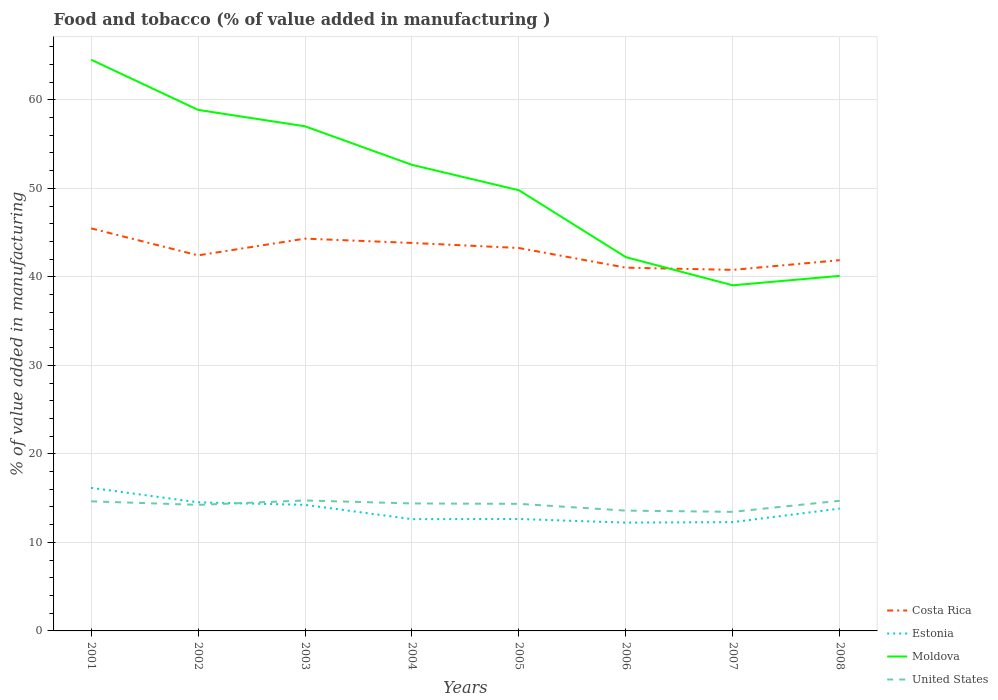Across all years, what is the maximum value added in manufacturing food and tobacco in Estonia?
Give a very brief answer. 12.23. What is the total value added in manufacturing food and tobacco in Costa Rica in the graph?
Offer a very short reply. 4.44. What is the difference between the highest and the second highest value added in manufacturing food and tobacco in Costa Rica?
Offer a very short reply. 4.69. How many lines are there?
Offer a very short reply. 4. What is the difference between two consecutive major ticks on the Y-axis?
Make the answer very short. 10. Are the values on the major ticks of Y-axis written in scientific E-notation?
Your answer should be compact. No. Does the graph contain grids?
Provide a succinct answer. Yes. Where does the legend appear in the graph?
Provide a short and direct response. Bottom right. What is the title of the graph?
Your answer should be compact. Food and tobacco (% of value added in manufacturing ). What is the label or title of the X-axis?
Your answer should be very brief. Years. What is the label or title of the Y-axis?
Make the answer very short. % of value added in manufacturing. What is the % of value added in manufacturing in Costa Rica in 2001?
Offer a terse response. 45.47. What is the % of value added in manufacturing in Estonia in 2001?
Your response must be concise. 16.16. What is the % of value added in manufacturing of Moldova in 2001?
Offer a terse response. 64.52. What is the % of value added in manufacturing in United States in 2001?
Your answer should be compact. 14.64. What is the % of value added in manufacturing in Costa Rica in 2002?
Give a very brief answer. 42.42. What is the % of value added in manufacturing in Estonia in 2002?
Offer a terse response. 14.53. What is the % of value added in manufacturing of Moldova in 2002?
Give a very brief answer. 58.86. What is the % of value added in manufacturing in United States in 2002?
Make the answer very short. 14.24. What is the % of value added in manufacturing in Costa Rica in 2003?
Your response must be concise. 44.31. What is the % of value added in manufacturing in Estonia in 2003?
Your response must be concise. 14.24. What is the % of value added in manufacturing of Moldova in 2003?
Offer a very short reply. 57. What is the % of value added in manufacturing of United States in 2003?
Offer a terse response. 14.74. What is the % of value added in manufacturing in Costa Rica in 2004?
Make the answer very short. 43.83. What is the % of value added in manufacturing of Estonia in 2004?
Provide a succinct answer. 12.63. What is the % of value added in manufacturing in Moldova in 2004?
Make the answer very short. 52.65. What is the % of value added in manufacturing of United States in 2004?
Ensure brevity in your answer.  14.4. What is the % of value added in manufacturing in Costa Rica in 2005?
Provide a short and direct response. 43.26. What is the % of value added in manufacturing of Estonia in 2005?
Provide a succinct answer. 12.64. What is the % of value added in manufacturing in Moldova in 2005?
Keep it short and to the point. 49.78. What is the % of value added in manufacturing of United States in 2005?
Provide a short and direct response. 14.35. What is the % of value added in manufacturing of Costa Rica in 2006?
Provide a short and direct response. 41.04. What is the % of value added in manufacturing in Estonia in 2006?
Provide a succinct answer. 12.23. What is the % of value added in manufacturing in Moldova in 2006?
Ensure brevity in your answer.  42.22. What is the % of value added in manufacturing of United States in 2006?
Provide a succinct answer. 13.59. What is the % of value added in manufacturing in Costa Rica in 2007?
Provide a succinct answer. 40.78. What is the % of value added in manufacturing in Estonia in 2007?
Your answer should be compact. 12.29. What is the % of value added in manufacturing in Moldova in 2007?
Your answer should be very brief. 39.04. What is the % of value added in manufacturing of United States in 2007?
Provide a succinct answer. 13.45. What is the % of value added in manufacturing of Costa Rica in 2008?
Your answer should be very brief. 41.88. What is the % of value added in manufacturing in Estonia in 2008?
Your response must be concise. 13.82. What is the % of value added in manufacturing in Moldova in 2008?
Keep it short and to the point. 40.11. What is the % of value added in manufacturing of United States in 2008?
Offer a terse response. 14.71. Across all years, what is the maximum % of value added in manufacturing of Costa Rica?
Offer a very short reply. 45.47. Across all years, what is the maximum % of value added in manufacturing in Estonia?
Keep it short and to the point. 16.16. Across all years, what is the maximum % of value added in manufacturing of Moldova?
Provide a succinct answer. 64.52. Across all years, what is the maximum % of value added in manufacturing of United States?
Ensure brevity in your answer.  14.74. Across all years, what is the minimum % of value added in manufacturing in Costa Rica?
Offer a terse response. 40.78. Across all years, what is the minimum % of value added in manufacturing of Estonia?
Give a very brief answer. 12.23. Across all years, what is the minimum % of value added in manufacturing of Moldova?
Make the answer very short. 39.04. Across all years, what is the minimum % of value added in manufacturing of United States?
Ensure brevity in your answer.  13.45. What is the total % of value added in manufacturing of Costa Rica in the graph?
Offer a terse response. 342.99. What is the total % of value added in manufacturing of Estonia in the graph?
Your response must be concise. 108.54. What is the total % of value added in manufacturing in Moldova in the graph?
Your response must be concise. 404.19. What is the total % of value added in manufacturing in United States in the graph?
Ensure brevity in your answer.  114.12. What is the difference between the % of value added in manufacturing in Costa Rica in 2001 and that in 2002?
Provide a succinct answer. 3.05. What is the difference between the % of value added in manufacturing of Estonia in 2001 and that in 2002?
Ensure brevity in your answer.  1.63. What is the difference between the % of value added in manufacturing of Moldova in 2001 and that in 2002?
Ensure brevity in your answer.  5.67. What is the difference between the % of value added in manufacturing of United States in 2001 and that in 2002?
Your answer should be compact. 0.4. What is the difference between the % of value added in manufacturing of Costa Rica in 2001 and that in 2003?
Offer a very short reply. 1.16. What is the difference between the % of value added in manufacturing of Estonia in 2001 and that in 2003?
Provide a short and direct response. 1.92. What is the difference between the % of value added in manufacturing of Moldova in 2001 and that in 2003?
Your answer should be very brief. 7.52. What is the difference between the % of value added in manufacturing of United States in 2001 and that in 2003?
Your answer should be compact. -0.1. What is the difference between the % of value added in manufacturing of Costa Rica in 2001 and that in 2004?
Give a very brief answer. 1.65. What is the difference between the % of value added in manufacturing in Estonia in 2001 and that in 2004?
Your answer should be very brief. 3.53. What is the difference between the % of value added in manufacturing in Moldova in 2001 and that in 2004?
Provide a succinct answer. 11.87. What is the difference between the % of value added in manufacturing of United States in 2001 and that in 2004?
Keep it short and to the point. 0.24. What is the difference between the % of value added in manufacturing of Costa Rica in 2001 and that in 2005?
Provide a succinct answer. 2.22. What is the difference between the % of value added in manufacturing of Estonia in 2001 and that in 2005?
Offer a very short reply. 3.52. What is the difference between the % of value added in manufacturing of Moldova in 2001 and that in 2005?
Your answer should be very brief. 14.75. What is the difference between the % of value added in manufacturing in United States in 2001 and that in 2005?
Give a very brief answer. 0.29. What is the difference between the % of value added in manufacturing of Costa Rica in 2001 and that in 2006?
Provide a succinct answer. 4.44. What is the difference between the % of value added in manufacturing in Estonia in 2001 and that in 2006?
Make the answer very short. 3.92. What is the difference between the % of value added in manufacturing in Moldova in 2001 and that in 2006?
Provide a succinct answer. 22.3. What is the difference between the % of value added in manufacturing in United States in 2001 and that in 2006?
Give a very brief answer. 1.05. What is the difference between the % of value added in manufacturing in Costa Rica in 2001 and that in 2007?
Give a very brief answer. 4.69. What is the difference between the % of value added in manufacturing in Estonia in 2001 and that in 2007?
Your response must be concise. 3.87. What is the difference between the % of value added in manufacturing in Moldova in 2001 and that in 2007?
Give a very brief answer. 25.48. What is the difference between the % of value added in manufacturing in United States in 2001 and that in 2007?
Provide a short and direct response. 1.19. What is the difference between the % of value added in manufacturing of Costa Rica in 2001 and that in 2008?
Your response must be concise. 3.59. What is the difference between the % of value added in manufacturing in Estonia in 2001 and that in 2008?
Ensure brevity in your answer.  2.34. What is the difference between the % of value added in manufacturing in Moldova in 2001 and that in 2008?
Your response must be concise. 24.42. What is the difference between the % of value added in manufacturing in United States in 2001 and that in 2008?
Provide a succinct answer. -0.06. What is the difference between the % of value added in manufacturing in Costa Rica in 2002 and that in 2003?
Offer a terse response. -1.89. What is the difference between the % of value added in manufacturing of Estonia in 2002 and that in 2003?
Give a very brief answer. 0.29. What is the difference between the % of value added in manufacturing in Moldova in 2002 and that in 2003?
Offer a very short reply. 1.86. What is the difference between the % of value added in manufacturing in United States in 2002 and that in 2003?
Your response must be concise. -0.5. What is the difference between the % of value added in manufacturing in Costa Rica in 2002 and that in 2004?
Provide a succinct answer. -1.4. What is the difference between the % of value added in manufacturing of Estonia in 2002 and that in 2004?
Provide a short and direct response. 1.9. What is the difference between the % of value added in manufacturing of Moldova in 2002 and that in 2004?
Offer a very short reply. 6.21. What is the difference between the % of value added in manufacturing of United States in 2002 and that in 2004?
Give a very brief answer. -0.16. What is the difference between the % of value added in manufacturing in Costa Rica in 2002 and that in 2005?
Keep it short and to the point. -0.83. What is the difference between the % of value added in manufacturing of Estonia in 2002 and that in 2005?
Keep it short and to the point. 1.88. What is the difference between the % of value added in manufacturing in Moldova in 2002 and that in 2005?
Give a very brief answer. 9.08. What is the difference between the % of value added in manufacturing in United States in 2002 and that in 2005?
Provide a short and direct response. -0.12. What is the difference between the % of value added in manufacturing of Costa Rica in 2002 and that in 2006?
Offer a very short reply. 1.39. What is the difference between the % of value added in manufacturing of Estonia in 2002 and that in 2006?
Give a very brief answer. 2.29. What is the difference between the % of value added in manufacturing of Moldova in 2002 and that in 2006?
Your response must be concise. 16.64. What is the difference between the % of value added in manufacturing in United States in 2002 and that in 2006?
Provide a short and direct response. 0.65. What is the difference between the % of value added in manufacturing of Costa Rica in 2002 and that in 2007?
Offer a terse response. 1.64. What is the difference between the % of value added in manufacturing of Estonia in 2002 and that in 2007?
Keep it short and to the point. 2.24. What is the difference between the % of value added in manufacturing in Moldova in 2002 and that in 2007?
Provide a succinct answer. 19.82. What is the difference between the % of value added in manufacturing of United States in 2002 and that in 2007?
Provide a short and direct response. 0.79. What is the difference between the % of value added in manufacturing in Costa Rica in 2002 and that in 2008?
Make the answer very short. 0.54. What is the difference between the % of value added in manufacturing in Estonia in 2002 and that in 2008?
Your answer should be very brief. 0.71. What is the difference between the % of value added in manufacturing of Moldova in 2002 and that in 2008?
Your answer should be compact. 18.75. What is the difference between the % of value added in manufacturing of United States in 2002 and that in 2008?
Your answer should be very brief. -0.47. What is the difference between the % of value added in manufacturing of Costa Rica in 2003 and that in 2004?
Provide a succinct answer. 0.49. What is the difference between the % of value added in manufacturing in Estonia in 2003 and that in 2004?
Offer a very short reply. 1.62. What is the difference between the % of value added in manufacturing in Moldova in 2003 and that in 2004?
Ensure brevity in your answer.  4.35. What is the difference between the % of value added in manufacturing of United States in 2003 and that in 2004?
Offer a very short reply. 0.34. What is the difference between the % of value added in manufacturing of Costa Rica in 2003 and that in 2005?
Offer a terse response. 1.06. What is the difference between the % of value added in manufacturing of Estonia in 2003 and that in 2005?
Provide a succinct answer. 1.6. What is the difference between the % of value added in manufacturing in Moldova in 2003 and that in 2005?
Provide a short and direct response. 7.22. What is the difference between the % of value added in manufacturing in United States in 2003 and that in 2005?
Your answer should be very brief. 0.38. What is the difference between the % of value added in manufacturing of Costa Rica in 2003 and that in 2006?
Your response must be concise. 3.28. What is the difference between the % of value added in manufacturing in Estonia in 2003 and that in 2006?
Your answer should be compact. 2.01. What is the difference between the % of value added in manufacturing in Moldova in 2003 and that in 2006?
Offer a terse response. 14.78. What is the difference between the % of value added in manufacturing of United States in 2003 and that in 2006?
Give a very brief answer. 1.15. What is the difference between the % of value added in manufacturing of Costa Rica in 2003 and that in 2007?
Your answer should be compact. 3.53. What is the difference between the % of value added in manufacturing of Estonia in 2003 and that in 2007?
Provide a short and direct response. 1.95. What is the difference between the % of value added in manufacturing of Moldova in 2003 and that in 2007?
Offer a very short reply. 17.96. What is the difference between the % of value added in manufacturing of United States in 2003 and that in 2007?
Your answer should be very brief. 1.29. What is the difference between the % of value added in manufacturing of Costa Rica in 2003 and that in 2008?
Provide a succinct answer. 2.43. What is the difference between the % of value added in manufacturing of Estonia in 2003 and that in 2008?
Give a very brief answer. 0.42. What is the difference between the % of value added in manufacturing of Moldova in 2003 and that in 2008?
Ensure brevity in your answer.  16.9. What is the difference between the % of value added in manufacturing of United States in 2003 and that in 2008?
Provide a succinct answer. 0.03. What is the difference between the % of value added in manufacturing in Costa Rica in 2004 and that in 2005?
Provide a short and direct response. 0.57. What is the difference between the % of value added in manufacturing of Estonia in 2004 and that in 2005?
Your answer should be compact. -0.02. What is the difference between the % of value added in manufacturing of Moldova in 2004 and that in 2005?
Offer a terse response. 2.87. What is the difference between the % of value added in manufacturing in United States in 2004 and that in 2005?
Provide a short and direct response. 0.04. What is the difference between the % of value added in manufacturing of Costa Rica in 2004 and that in 2006?
Your answer should be compact. 2.79. What is the difference between the % of value added in manufacturing in Estonia in 2004 and that in 2006?
Keep it short and to the point. 0.39. What is the difference between the % of value added in manufacturing of Moldova in 2004 and that in 2006?
Your answer should be compact. 10.43. What is the difference between the % of value added in manufacturing in United States in 2004 and that in 2006?
Make the answer very short. 0.81. What is the difference between the % of value added in manufacturing of Costa Rica in 2004 and that in 2007?
Provide a succinct answer. 3.04. What is the difference between the % of value added in manufacturing in Estonia in 2004 and that in 2007?
Ensure brevity in your answer.  0.33. What is the difference between the % of value added in manufacturing of Moldova in 2004 and that in 2007?
Make the answer very short. 13.61. What is the difference between the % of value added in manufacturing of United States in 2004 and that in 2007?
Offer a terse response. 0.95. What is the difference between the % of value added in manufacturing in Costa Rica in 2004 and that in 2008?
Make the answer very short. 1.95. What is the difference between the % of value added in manufacturing of Estonia in 2004 and that in 2008?
Make the answer very short. -1.19. What is the difference between the % of value added in manufacturing of Moldova in 2004 and that in 2008?
Ensure brevity in your answer.  12.54. What is the difference between the % of value added in manufacturing in United States in 2004 and that in 2008?
Make the answer very short. -0.31. What is the difference between the % of value added in manufacturing of Costa Rica in 2005 and that in 2006?
Keep it short and to the point. 2.22. What is the difference between the % of value added in manufacturing in Estonia in 2005 and that in 2006?
Your response must be concise. 0.41. What is the difference between the % of value added in manufacturing of Moldova in 2005 and that in 2006?
Provide a succinct answer. 7.56. What is the difference between the % of value added in manufacturing in United States in 2005 and that in 2006?
Offer a very short reply. 0.76. What is the difference between the % of value added in manufacturing in Costa Rica in 2005 and that in 2007?
Offer a very short reply. 2.47. What is the difference between the % of value added in manufacturing in Estonia in 2005 and that in 2007?
Give a very brief answer. 0.35. What is the difference between the % of value added in manufacturing of Moldova in 2005 and that in 2007?
Make the answer very short. 10.74. What is the difference between the % of value added in manufacturing of United States in 2005 and that in 2007?
Offer a very short reply. 0.9. What is the difference between the % of value added in manufacturing in Costa Rica in 2005 and that in 2008?
Offer a very short reply. 1.38. What is the difference between the % of value added in manufacturing in Estonia in 2005 and that in 2008?
Keep it short and to the point. -1.18. What is the difference between the % of value added in manufacturing in Moldova in 2005 and that in 2008?
Provide a short and direct response. 9.67. What is the difference between the % of value added in manufacturing of United States in 2005 and that in 2008?
Ensure brevity in your answer.  -0.35. What is the difference between the % of value added in manufacturing of Costa Rica in 2006 and that in 2007?
Your response must be concise. 0.25. What is the difference between the % of value added in manufacturing of Estonia in 2006 and that in 2007?
Your answer should be very brief. -0.06. What is the difference between the % of value added in manufacturing of Moldova in 2006 and that in 2007?
Offer a very short reply. 3.18. What is the difference between the % of value added in manufacturing in United States in 2006 and that in 2007?
Give a very brief answer. 0.14. What is the difference between the % of value added in manufacturing in Costa Rica in 2006 and that in 2008?
Ensure brevity in your answer.  -0.84. What is the difference between the % of value added in manufacturing in Estonia in 2006 and that in 2008?
Offer a terse response. -1.58. What is the difference between the % of value added in manufacturing in Moldova in 2006 and that in 2008?
Offer a very short reply. 2.11. What is the difference between the % of value added in manufacturing in United States in 2006 and that in 2008?
Your response must be concise. -1.11. What is the difference between the % of value added in manufacturing of Costa Rica in 2007 and that in 2008?
Keep it short and to the point. -1.1. What is the difference between the % of value added in manufacturing in Estonia in 2007 and that in 2008?
Ensure brevity in your answer.  -1.53. What is the difference between the % of value added in manufacturing in Moldova in 2007 and that in 2008?
Your answer should be very brief. -1.06. What is the difference between the % of value added in manufacturing in United States in 2007 and that in 2008?
Offer a terse response. -1.25. What is the difference between the % of value added in manufacturing in Costa Rica in 2001 and the % of value added in manufacturing in Estonia in 2002?
Make the answer very short. 30.95. What is the difference between the % of value added in manufacturing in Costa Rica in 2001 and the % of value added in manufacturing in Moldova in 2002?
Make the answer very short. -13.39. What is the difference between the % of value added in manufacturing of Costa Rica in 2001 and the % of value added in manufacturing of United States in 2002?
Keep it short and to the point. 31.23. What is the difference between the % of value added in manufacturing in Estonia in 2001 and the % of value added in manufacturing in Moldova in 2002?
Provide a short and direct response. -42.7. What is the difference between the % of value added in manufacturing in Estonia in 2001 and the % of value added in manufacturing in United States in 2002?
Provide a short and direct response. 1.92. What is the difference between the % of value added in manufacturing of Moldova in 2001 and the % of value added in manufacturing of United States in 2002?
Keep it short and to the point. 50.29. What is the difference between the % of value added in manufacturing of Costa Rica in 2001 and the % of value added in manufacturing of Estonia in 2003?
Give a very brief answer. 31.23. What is the difference between the % of value added in manufacturing in Costa Rica in 2001 and the % of value added in manufacturing in Moldova in 2003?
Provide a succinct answer. -11.53. What is the difference between the % of value added in manufacturing of Costa Rica in 2001 and the % of value added in manufacturing of United States in 2003?
Your answer should be compact. 30.73. What is the difference between the % of value added in manufacturing of Estonia in 2001 and the % of value added in manufacturing of Moldova in 2003?
Offer a very short reply. -40.84. What is the difference between the % of value added in manufacturing of Estonia in 2001 and the % of value added in manufacturing of United States in 2003?
Your response must be concise. 1.42. What is the difference between the % of value added in manufacturing in Moldova in 2001 and the % of value added in manufacturing in United States in 2003?
Give a very brief answer. 49.79. What is the difference between the % of value added in manufacturing of Costa Rica in 2001 and the % of value added in manufacturing of Estonia in 2004?
Your answer should be compact. 32.85. What is the difference between the % of value added in manufacturing of Costa Rica in 2001 and the % of value added in manufacturing of Moldova in 2004?
Keep it short and to the point. -7.18. What is the difference between the % of value added in manufacturing of Costa Rica in 2001 and the % of value added in manufacturing of United States in 2004?
Provide a succinct answer. 31.07. What is the difference between the % of value added in manufacturing of Estonia in 2001 and the % of value added in manufacturing of Moldova in 2004?
Give a very brief answer. -36.49. What is the difference between the % of value added in manufacturing in Estonia in 2001 and the % of value added in manufacturing in United States in 2004?
Offer a terse response. 1.76. What is the difference between the % of value added in manufacturing of Moldova in 2001 and the % of value added in manufacturing of United States in 2004?
Keep it short and to the point. 50.12. What is the difference between the % of value added in manufacturing of Costa Rica in 2001 and the % of value added in manufacturing of Estonia in 2005?
Keep it short and to the point. 32.83. What is the difference between the % of value added in manufacturing of Costa Rica in 2001 and the % of value added in manufacturing of Moldova in 2005?
Give a very brief answer. -4.31. What is the difference between the % of value added in manufacturing in Costa Rica in 2001 and the % of value added in manufacturing in United States in 2005?
Provide a succinct answer. 31.12. What is the difference between the % of value added in manufacturing in Estonia in 2001 and the % of value added in manufacturing in Moldova in 2005?
Provide a succinct answer. -33.62. What is the difference between the % of value added in manufacturing of Estonia in 2001 and the % of value added in manufacturing of United States in 2005?
Provide a short and direct response. 1.8. What is the difference between the % of value added in manufacturing in Moldova in 2001 and the % of value added in manufacturing in United States in 2005?
Ensure brevity in your answer.  50.17. What is the difference between the % of value added in manufacturing in Costa Rica in 2001 and the % of value added in manufacturing in Estonia in 2006?
Offer a terse response. 33.24. What is the difference between the % of value added in manufacturing in Costa Rica in 2001 and the % of value added in manufacturing in Moldova in 2006?
Make the answer very short. 3.25. What is the difference between the % of value added in manufacturing of Costa Rica in 2001 and the % of value added in manufacturing of United States in 2006?
Ensure brevity in your answer.  31.88. What is the difference between the % of value added in manufacturing of Estonia in 2001 and the % of value added in manufacturing of Moldova in 2006?
Keep it short and to the point. -26.06. What is the difference between the % of value added in manufacturing in Estonia in 2001 and the % of value added in manufacturing in United States in 2006?
Ensure brevity in your answer.  2.57. What is the difference between the % of value added in manufacturing of Moldova in 2001 and the % of value added in manufacturing of United States in 2006?
Provide a succinct answer. 50.93. What is the difference between the % of value added in manufacturing in Costa Rica in 2001 and the % of value added in manufacturing in Estonia in 2007?
Provide a succinct answer. 33.18. What is the difference between the % of value added in manufacturing of Costa Rica in 2001 and the % of value added in manufacturing of Moldova in 2007?
Provide a succinct answer. 6.43. What is the difference between the % of value added in manufacturing in Costa Rica in 2001 and the % of value added in manufacturing in United States in 2007?
Give a very brief answer. 32.02. What is the difference between the % of value added in manufacturing of Estonia in 2001 and the % of value added in manufacturing of Moldova in 2007?
Give a very brief answer. -22.88. What is the difference between the % of value added in manufacturing of Estonia in 2001 and the % of value added in manufacturing of United States in 2007?
Ensure brevity in your answer.  2.71. What is the difference between the % of value added in manufacturing of Moldova in 2001 and the % of value added in manufacturing of United States in 2007?
Your response must be concise. 51.07. What is the difference between the % of value added in manufacturing in Costa Rica in 2001 and the % of value added in manufacturing in Estonia in 2008?
Your answer should be compact. 31.65. What is the difference between the % of value added in manufacturing of Costa Rica in 2001 and the % of value added in manufacturing of Moldova in 2008?
Your response must be concise. 5.37. What is the difference between the % of value added in manufacturing of Costa Rica in 2001 and the % of value added in manufacturing of United States in 2008?
Offer a very short reply. 30.77. What is the difference between the % of value added in manufacturing of Estonia in 2001 and the % of value added in manufacturing of Moldova in 2008?
Ensure brevity in your answer.  -23.95. What is the difference between the % of value added in manufacturing in Estonia in 2001 and the % of value added in manufacturing in United States in 2008?
Give a very brief answer. 1.45. What is the difference between the % of value added in manufacturing of Moldova in 2001 and the % of value added in manufacturing of United States in 2008?
Ensure brevity in your answer.  49.82. What is the difference between the % of value added in manufacturing in Costa Rica in 2002 and the % of value added in manufacturing in Estonia in 2003?
Your response must be concise. 28.18. What is the difference between the % of value added in manufacturing in Costa Rica in 2002 and the % of value added in manufacturing in Moldova in 2003?
Your response must be concise. -14.58. What is the difference between the % of value added in manufacturing of Costa Rica in 2002 and the % of value added in manufacturing of United States in 2003?
Keep it short and to the point. 27.69. What is the difference between the % of value added in manufacturing of Estonia in 2002 and the % of value added in manufacturing of Moldova in 2003?
Offer a very short reply. -42.48. What is the difference between the % of value added in manufacturing in Estonia in 2002 and the % of value added in manufacturing in United States in 2003?
Ensure brevity in your answer.  -0.21. What is the difference between the % of value added in manufacturing in Moldova in 2002 and the % of value added in manufacturing in United States in 2003?
Keep it short and to the point. 44.12. What is the difference between the % of value added in manufacturing of Costa Rica in 2002 and the % of value added in manufacturing of Estonia in 2004?
Provide a succinct answer. 29.8. What is the difference between the % of value added in manufacturing of Costa Rica in 2002 and the % of value added in manufacturing of Moldova in 2004?
Offer a terse response. -10.22. What is the difference between the % of value added in manufacturing of Costa Rica in 2002 and the % of value added in manufacturing of United States in 2004?
Make the answer very short. 28.03. What is the difference between the % of value added in manufacturing in Estonia in 2002 and the % of value added in manufacturing in Moldova in 2004?
Make the answer very short. -38.12. What is the difference between the % of value added in manufacturing in Estonia in 2002 and the % of value added in manufacturing in United States in 2004?
Make the answer very short. 0.13. What is the difference between the % of value added in manufacturing of Moldova in 2002 and the % of value added in manufacturing of United States in 2004?
Offer a very short reply. 44.46. What is the difference between the % of value added in manufacturing of Costa Rica in 2002 and the % of value added in manufacturing of Estonia in 2005?
Provide a short and direct response. 29.78. What is the difference between the % of value added in manufacturing of Costa Rica in 2002 and the % of value added in manufacturing of Moldova in 2005?
Make the answer very short. -7.35. What is the difference between the % of value added in manufacturing in Costa Rica in 2002 and the % of value added in manufacturing in United States in 2005?
Give a very brief answer. 28.07. What is the difference between the % of value added in manufacturing in Estonia in 2002 and the % of value added in manufacturing in Moldova in 2005?
Give a very brief answer. -35.25. What is the difference between the % of value added in manufacturing of Estonia in 2002 and the % of value added in manufacturing of United States in 2005?
Offer a very short reply. 0.17. What is the difference between the % of value added in manufacturing of Moldova in 2002 and the % of value added in manufacturing of United States in 2005?
Make the answer very short. 44.5. What is the difference between the % of value added in manufacturing of Costa Rica in 2002 and the % of value added in manufacturing of Estonia in 2006?
Your answer should be very brief. 30.19. What is the difference between the % of value added in manufacturing in Costa Rica in 2002 and the % of value added in manufacturing in Moldova in 2006?
Your response must be concise. 0.2. What is the difference between the % of value added in manufacturing of Costa Rica in 2002 and the % of value added in manufacturing of United States in 2006?
Provide a short and direct response. 28.83. What is the difference between the % of value added in manufacturing of Estonia in 2002 and the % of value added in manufacturing of Moldova in 2006?
Provide a short and direct response. -27.7. What is the difference between the % of value added in manufacturing in Estonia in 2002 and the % of value added in manufacturing in United States in 2006?
Make the answer very short. 0.94. What is the difference between the % of value added in manufacturing in Moldova in 2002 and the % of value added in manufacturing in United States in 2006?
Offer a very short reply. 45.27. What is the difference between the % of value added in manufacturing in Costa Rica in 2002 and the % of value added in manufacturing in Estonia in 2007?
Provide a succinct answer. 30.13. What is the difference between the % of value added in manufacturing in Costa Rica in 2002 and the % of value added in manufacturing in Moldova in 2007?
Provide a succinct answer. 3.38. What is the difference between the % of value added in manufacturing in Costa Rica in 2002 and the % of value added in manufacturing in United States in 2007?
Provide a succinct answer. 28.97. What is the difference between the % of value added in manufacturing of Estonia in 2002 and the % of value added in manufacturing of Moldova in 2007?
Your answer should be compact. -24.52. What is the difference between the % of value added in manufacturing in Estonia in 2002 and the % of value added in manufacturing in United States in 2007?
Your response must be concise. 1.08. What is the difference between the % of value added in manufacturing of Moldova in 2002 and the % of value added in manufacturing of United States in 2007?
Ensure brevity in your answer.  45.41. What is the difference between the % of value added in manufacturing in Costa Rica in 2002 and the % of value added in manufacturing in Estonia in 2008?
Provide a short and direct response. 28.61. What is the difference between the % of value added in manufacturing of Costa Rica in 2002 and the % of value added in manufacturing of Moldova in 2008?
Your response must be concise. 2.32. What is the difference between the % of value added in manufacturing in Costa Rica in 2002 and the % of value added in manufacturing in United States in 2008?
Ensure brevity in your answer.  27.72. What is the difference between the % of value added in manufacturing of Estonia in 2002 and the % of value added in manufacturing of Moldova in 2008?
Provide a succinct answer. -25.58. What is the difference between the % of value added in manufacturing in Estonia in 2002 and the % of value added in manufacturing in United States in 2008?
Ensure brevity in your answer.  -0.18. What is the difference between the % of value added in manufacturing of Moldova in 2002 and the % of value added in manufacturing of United States in 2008?
Your response must be concise. 44.15. What is the difference between the % of value added in manufacturing in Costa Rica in 2003 and the % of value added in manufacturing in Estonia in 2004?
Ensure brevity in your answer.  31.69. What is the difference between the % of value added in manufacturing of Costa Rica in 2003 and the % of value added in manufacturing of Moldova in 2004?
Provide a short and direct response. -8.34. What is the difference between the % of value added in manufacturing in Costa Rica in 2003 and the % of value added in manufacturing in United States in 2004?
Offer a very short reply. 29.91. What is the difference between the % of value added in manufacturing of Estonia in 2003 and the % of value added in manufacturing of Moldova in 2004?
Your response must be concise. -38.41. What is the difference between the % of value added in manufacturing of Estonia in 2003 and the % of value added in manufacturing of United States in 2004?
Your answer should be very brief. -0.16. What is the difference between the % of value added in manufacturing of Moldova in 2003 and the % of value added in manufacturing of United States in 2004?
Provide a succinct answer. 42.6. What is the difference between the % of value added in manufacturing of Costa Rica in 2003 and the % of value added in manufacturing of Estonia in 2005?
Offer a terse response. 31.67. What is the difference between the % of value added in manufacturing in Costa Rica in 2003 and the % of value added in manufacturing in Moldova in 2005?
Ensure brevity in your answer.  -5.47. What is the difference between the % of value added in manufacturing in Costa Rica in 2003 and the % of value added in manufacturing in United States in 2005?
Keep it short and to the point. 29.96. What is the difference between the % of value added in manufacturing in Estonia in 2003 and the % of value added in manufacturing in Moldova in 2005?
Ensure brevity in your answer.  -35.54. What is the difference between the % of value added in manufacturing in Estonia in 2003 and the % of value added in manufacturing in United States in 2005?
Ensure brevity in your answer.  -0.11. What is the difference between the % of value added in manufacturing of Moldova in 2003 and the % of value added in manufacturing of United States in 2005?
Your response must be concise. 42.65. What is the difference between the % of value added in manufacturing in Costa Rica in 2003 and the % of value added in manufacturing in Estonia in 2006?
Provide a short and direct response. 32.08. What is the difference between the % of value added in manufacturing in Costa Rica in 2003 and the % of value added in manufacturing in Moldova in 2006?
Offer a terse response. 2.09. What is the difference between the % of value added in manufacturing in Costa Rica in 2003 and the % of value added in manufacturing in United States in 2006?
Offer a very short reply. 30.72. What is the difference between the % of value added in manufacturing of Estonia in 2003 and the % of value added in manufacturing of Moldova in 2006?
Your answer should be compact. -27.98. What is the difference between the % of value added in manufacturing in Estonia in 2003 and the % of value added in manufacturing in United States in 2006?
Your response must be concise. 0.65. What is the difference between the % of value added in manufacturing in Moldova in 2003 and the % of value added in manufacturing in United States in 2006?
Provide a short and direct response. 43.41. What is the difference between the % of value added in manufacturing of Costa Rica in 2003 and the % of value added in manufacturing of Estonia in 2007?
Offer a terse response. 32.02. What is the difference between the % of value added in manufacturing of Costa Rica in 2003 and the % of value added in manufacturing of Moldova in 2007?
Your response must be concise. 5.27. What is the difference between the % of value added in manufacturing of Costa Rica in 2003 and the % of value added in manufacturing of United States in 2007?
Ensure brevity in your answer.  30.86. What is the difference between the % of value added in manufacturing in Estonia in 2003 and the % of value added in manufacturing in Moldova in 2007?
Your response must be concise. -24.8. What is the difference between the % of value added in manufacturing in Estonia in 2003 and the % of value added in manufacturing in United States in 2007?
Your answer should be compact. 0.79. What is the difference between the % of value added in manufacturing of Moldova in 2003 and the % of value added in manufacturing of United States in 2007?
Your answer should be very brief. 43.55. What is the difference between the % of value added in manufacturing in Costa Rica in 2003 and the % of value added in manufacturing in Estonia in 2008?
Keep it short and to the point. 30.49. What is the difference between the % of value added in manufacturing in Costa Rica in 2003 and the % of value added in manufacturing in Moldova in 2008?
Your answer should be very brief. 4.21. What is the difference between the % of value added in manufacturing in Costa Rica in 2003 and the % of value added in manufacturing in United States in 2008?
Your answer should be very brief. 29.61. What is the difference between the % of value added in manufacturing in Estonia in 2003 and the % of value added in manufacturing in Moldova in 2008?
Provide a short and direct response. -25.87. What is the difference between the % of value added in manufacturing of Estonia in 2003 and the % of value added in manufacturing of United States in 2008?
Keep it short and to the point. -0.46. What is the difference between the % of value added in manufacturing in Moldova in 2003 and the % of value added in manufacturing in United States in 2008?
Give a very brief answer. 42.3. What is the difference between the % of value added in manufacturing in Costa Rica in 2004 and the % of value added in manufacturing in Estonia in 2005?
Keep it short and to the point. 31.18. What is the difference between the % of value added in manufacturing of Costa Rica in 2004 and the % of value added in manufacturing of Moldova in 2005?
Offer a very short reply. -5.95. What is the difference between the % of value added in manufacturing of Costa Rica in 2004 and the % of value added in manufacturing of United States in 2005?
Ensure brevity in your answer.  29.47. What is the difference between the % of value added in manufacturing in Estonia in 2004 and the % of value added in manufacturing in Moldova in 2005?
Make the answer very short. -37.15. What is the difference between the % of value added in manufacturing in Estonia in 2004 and the % of value added in manufacturing in United States in 2005?
Ensure brevity in your answer.  -1.73. What is the difference between the % of value added in manufacturing of Moldova in 2004 and the % of value added in manufacturing of United States in 2005?
Your response must be concise. 38.29. What is the difference between the % of value added in manufacturing of Costa Rica in 2004 and the % of value added in manufacturing of Estonia in 2006?
Offer a very short reply. 31.59. What is the difference between the % of value added in manufacturing of Costa Rica in 2004 and the % of value added in manufacturing of Moldova in 2006?
Give a very brief answer. 1.6. What is the difference between the % of value added in manufacturing of Costa Rica in 2004 and the % of value added in manufacturing of United States in 2006?
Your answer should be compact. 30.24. What is the difference between the % of value added in manufacturing in Estonia in 2004 and the % of value added in manufacturing in Moldova in 2006?
Your response must be concise. -29.6. What is the difference between the % of value added in manufacturing in Estonia in 2004 and the % of value added in manufacturing in United States in 2006?
Make the answer very short. -0.96. What is the difference between the % of value added in manufacturing in Moldova in 2004 and the % of value added in manufacturing in United States in 2006?
Offer a very short reply. 39.06. What is the difference between the % of value added in manufacturing of Costa Rica in 2004 and the % of value added in manufacturing of Estonia in 2007?
Keep it short and to the point. 31.54. What is the difference between the % of value added in manufacturing of Costa Rica in 2004 and the % of value added in manufacturing of Moldova in 2007?
Your answer should be compact. 4.78. What is the difference between the % of value added in manufacturing of Costa Rica in 2004 and the % of value added in manufacturing of United States in 2007?
Give a very brief answer. 30.38. What is the difference between the % of value added in manufacturing of Estonia in 2004 and the % of value added in manufacturing of Moldova in 2007?
Your answer should be very brief. -26.42. What is the difference between the % of value added in manufacturing in Estonia in 2004 and the % of value added in manufacturing in United States in 2007?
Your answer should be very brief. -0.83. What is the difference between the % of value added in manufacturing in Moldova in 2004 and the % of value added in manufacturing in United States in 2007?
Provide a short and direct response. 39.2. What is the difference between the % of value added in manufacturing in Costa Rica in 2004 and the % of value added in manufacturing in Estonia in 2008?
Offer a terse response. 30.01. What is the difference between the % of value added in manufacturing of Costa Rica in 2004 and the % of value added in manufacturing of Moldova in 2008?
Keep it short and to the point. 3.72. What is the difference between the % of value added in manufacturing in Costa Rica in 2004 and the % of value added in manufacturing in United States in 2008?
Provide a succinct answer. 29.12. What is the difference between the % of value added in manufacturing in Estonia in 2004 and the % of value added in manufacturing in Moldova in 2008?
Provide a short and direct response. -27.48. What is the difference between the % of value added in manufacturing in Estonia in 2004 and the % of value added in manufacturing in United States in 2008?
Your answer should be compact. -2.08. What is the difference between the % of value added in manufacturing in Moldova in 2004 and the % of value added in manufacturing in United States in 2008?
Make the answer very short. 37.94. What is the difference between the % of value added in manufacturing of Costa Rica in 2005 and the % of value added in manufacturing of Estonia in 2006?
Offer a very short reply. 31.02. What is the difference between the % of value added in manufacturing of Costa Rica in 2005 and the % of value added in manufacturing of Moldova in 2006?
Keep it short and to the point. 1.03. What is the difference between the % of value added in manufacturing of Costa Rica in 2005 and the % of value added in manufacturing of United States in 2006?
Ensure brevity in your answer.  29.67. What is the difference between the % of value added in manufacturing in Estonia in 2005 and the % of value added in manufacturing in Moldova in 2006?
Offer a very short reply. -29.58. What is the difference between the % of value added in manufacturing in Estonia in 2005 and the % of value added in manufacturing in United States in 2006?
Your response must be concise. -0.95. What is the difference between the % of value added in manufacturing of Moldova in 2005 and the % of value added in manufacturing of United States in 2006?
Offer a terse response. 36.19. What is the difference between the % of value added in manufacturing in Costa Rica in 2005 and the % of value added in manufacturing in Estonia in 2007?
Your response must be concise. 30.97. What is the difference between the % of value added in manufacturing of Costa Rica in 2005 and the % of value added in manufacturing of Moldova in 2007?
Your answer should be very brief. 4.21. What is the difference between the % of value added in manufacturing in Costa Rica in 2005 and the % of value added in manufacturing in United States in 2007?
Ensure brevity in your answer.  29.81. What is the difference between the % of value added in manufacturing of Estonia in 2005 and the % of value added in manufacturing of Moldova in 2007?
Your response must be concise. -26.4. What is the difference between the % of value added in manufacturing in Estonia in 2005 and the % of value added in manufacturing in United States in 2007?
Ensure brevity in your answer.  -0.81. What is the difference between the % of value added in manufacturing in Moldova in 2005 and the % of value added in manufacturing in United States in 2007?
Your response must be concise. 36.33. What is the difference between the % of value added in manufacturing in Costa Rica in 2005 and the % of value added in manufacturing in Estonia in 2008?
Give a very brief answer. 29.44. What is the difference between the % of value added in manufacturing of Costa Rica in 2005 and the % of value added in manufacturing of Moldova in 2008?
Offer a very short reply. 3.15. What is the difference between the % of value added in manufacturing of Costa Rica in 2005 and the % of value added in manufacturing of United States in 2008?
Provide a succinct answer. 28.55. What is the difference between the % of value added in manufacturing in Estonia in 2005 and the % of value added in manufacturing in Moldova in 2008?
Offer a very short reply. -27.47. What is the difference between the % of value added in manufacturing in Estonia in 2005 and the % of value added in manufacturing in United States in 2008?
Keep it short and to the point. -2.06. What is the difference between the % of value added in manufacturing of Moldova in 2005 and the % of value added in manufacturing of United States in 2008?
Offer a very short reply. 35.07. What is the difference between the % of value added in manufacturing in Costa Rica in 2006 and the % of value added in manufacturing in Estonia in 2007?
Give a very brief answer. 28.75. What is the difference between the % of value added in manufacturing of Costa Rica in 2006 and the % of value added in manufacturing of Moldova in 2007?
Make the answer very short. 1.99. What is the difference between the % of value added in manufacturing of Costa Rica in 2006 and the % of value added in manufacturing of United States in 2007?
Offer a terse response. 27.59. What is the difference between the % of value added in manufacturing of Estonia in 2006 and the % of value added in manufacturing of Moldova in 2007?
Keep it short and to the point. -26.81. What is the difference between the % of value added in manufacturing in Estonia in 2006 and the % of value added in manufacturing in United States in 2007?
Give a very brief answer. -1.22. What is the difference between the % of value added in manufacturing in Moldova in 2006 and the % of value added in manufacturing in United States in 2007?
Make the answer very short. 28.77. What is the difference between the % of value added in manufacturing in Costa Rica in 2006 and the % of value added in manufacturing in Estonia in 2008?
Your answer should be compact. 27.22. What is the difference between the % of value added in manufacturing in Costa Rica in 2006 and the % of value added in manufacturing in Moldova in 2008?
Make the answer very short. 0.93. What is the difference between the % of value added in manufacturing in Costa Rica in 2006 and the % of value added in manufacturing in United States in 2008?
Give a very brief answer. 26.33. What is the difference between the % of value added in manufacturing in Estonia in 2006 and the % of value added in manufacturing in Moldova in 2008?
Make the answer very short. -27.87. What is the difference between the % of value added in manufacturing of Estonia in 2006 and the % of value added in manufacturing of United States in 2008?
Offer a terse response. -2.47. What is the difference between the % of value added in manufacturing in Moldova in 2006 and the % of value added in manufacturing in United States in 2008?
Keep it short and to the point. 27.52. What is the difference between the % of value added in manufacturing of Costa Rica in 2007 and the % of value added in manufacturing of Estonia in 2008?
Your answer should be very brief. 26.97. What is the difference between the % of value added in manufacturing in Costa Rica in 2007 and the % of value added in manufacturing in Moldova in 2008?
Offer a terse response. 0.68. What is the difference between the % of value added in manufacturing in Costa Rica in 2007 and the % of value added in manufacturing in United States in 2008?
Give a very brief answer. 26.08. What is the difference between the % of value added in manufacturing of Estonia in 2007 and the % of value added in manufacturing of Moldova in 2008?
Provide a short and direct response. -27.82. What is the difference between the % of value added in manufacturing in Estonia in 2007 and the % of value added in manufacturing in United States in 2008?
Your response must be concise. -2.41. What is the difference between the % of value added in manufacturing in Moldova in 2007 and the % of value added in manufacturing in United States in 2008?
Give a very brief answer. 24.34. What is the average % of value added in manufacturing of Costa Rica per year?
Keep it short and to the point. 42.87. What is the average % of value added in manufacturing of Estonia per year?
Offer a very short reply. 13.57. What is the average % of value added in manufacturing in Moldova per year?
Ensure brevity in your answer.  50.52. What is the average % of value added in manufacturing in United States per year?
Provide a succinct answer. 14.26. In the year 2001, what is the difference between the % of value added in manufacturing of Costa Rica and % of value added in manufacturing of Estonia?
Give a very brief answer. 29.31. In the year 2001, what is the difference between the % of value added in manufacturing of Costa Rica and % of value added in manufacturing of Moldova?
Make the answer very short. -19.05. In the year 2001, what is the difference between the % of value added in manufacturing of Costa Rica and % of value added in manufacturing of United States?
Make the answer very short. 30.83. In the year 2001, what is the difference between the % of value added in manufacturing in Estonia and % of value added in manufacturing in Moldova?
Keep it short and to the point. -48.36. In the year 2001, what is the difference between the % of value added in manufacturing of Estonia and % of value added in manufacturing of United States?
Provide a succinct answer. 1.52. In the year 2001, what is the difference between the % of value added in manufacturing in Moldova and % of value added in manufacturing in United States?
Offer a terse response. 49.88. In the year 2002, what is the difference between the % of value added in manufacturing in Costa Rica and % of value added in manufacturing in Estonia?
Your answer should be compact. 27.9. In the year 2002, what is the difference between the % of value added in manufacturing of Costa Rica and % of value added in manufacturing of Moldova?
Your response must be concise. -16.43. In the year 2002, what is the difference between the % of value added in manufacturing of Costa Rica and % of value added in manufacturing of United States?
Offer a very short reply. 28.19. In the year 2002, what is the difference between the % of value added in manufacturing of Estonia and % of value added in manufacturing of Moldova?
Ensure brevity in your answer.  -44.33. In the year 2002, what is the difference between the % of value added in manufacturing in Estonia and % of value added in manufacturing in United States?
Give a very brief answer. 0.29. In the year 2002, what is the difference between the % of value added in manufacturing of Moldova and % of value added in manufacturing of United States?
Keep it short and to the point. 44.62. In the year 2003, what is the difference between the % of value added in manufacturing of Costa Rica and % of value added in manufacturing of Estonia?
Give a very brief answer. 30.07. In the year 2003, what is the difference between the % of value added in manufacturing in Costa Rica and % of value added in manufacturing in Moldova?
Your response must be concise. -12.69. In the year 2003, what is the difference between the % of value added in manufacturing in Costa Rica and % of value added in manufacturing in United States?
Ensure brevity in your answer.  29.58. In the year 2003, what is the difference between the % of value added in manufacturing of Estonia and % of value added in manufacturing of Moldova?
Your answer should be compact. -42.76. In the year 2003, what is the difference between the % of value added in manufacturing of Estonia and % of value added in manufacturing of United States?
Make the answer very short. -0.5. In the year 2003, what is the difference between the % of value added in manufacturing of Moldova and % of value added in manufacturing of United States?
Ensure brevity in your answer.  42.27. In the year 2004, what is the difference between the % of value added in manufacturing in Costa Rica and % of value added in manufacturing in Estonia?
Your response must be concise. 31.2. In the year 2004, what is the difference between the % of value added in manufacturing in Costa Rica and % of value added in manufacturing in Moldova?
Offer a very short reply. -8.82. In the year 2004, what is the difference between the % of value added in manufacturing of Costa Rica and % of value added in manufacturing of United States?
Offer a very short reply. 29.43. In the year 2004, what is the difference between the % of value added in manufacturing in Estonia and % of value added in manufacturing in Moldova?
Your response must be concise. -40.02. In the year 2004, what is the difference between the % of value added in manufacturing in Estonia and % of value added in manufacturing in United States?
Provide a succinct answer. -1.77. In the year 2004, what is the difference between the % of value added in manufacturing of Moldova and % of value added in manufacturing of United States?
Keep it short and to the point. 38.25. In the year 2005, what is the difference between the % of value added in manufacturing of Costa Rica and % of value added in manufacturing of Estonia?
Offer a terse response. 30.61. In the year 2005, what is the difference between the % of value added in manufacturing of Costa Rica and % of value added in manufacturing of Moldova?
Offer a terse response. -6.52. In the year 2005, what is the difference between the % of value added in manufacturing of Costa Rica and % of value added in manufacturing of United States?
Offer a terse response. 28.9. In the year 2005, what is the difference between the % of value added in manufacturing in Estonia and % of value added in manufacturing in Moldova?
Offer a terse response. -37.14. In the year 2005, what is the difference between the % of value added in manufacturing in Estonia and % of value added in manufacturing in United States?
Make the answer very short. -1.71. In the year 2005, what is the difference between the % of value added in manufacturing in Moldova and % of value added in manufacturing in United States?
Ensure brevity in your answer.  35.42. In the year 2006, what is the difference between the % of value added in manufacturing in Costa Rica and % of value added in manufacturing in Estonia?
Your answer should be compact. 28.8. In the year 2006, what is the difference between the % of value added in manufacturing in Costa Rica and % of value added in manufacturing in Moldova?
Offer a terse response. -1.19. In the year 2006, what is the difference between the % of value added in manufacturing in Costa Rica and % of value added in manufacturing in United States?
Ensure brevity in your answer.  27.45. In the year 2006, what is the difference between the % of value added in manufacturing in Estonia and % of value added in manufacturing in Moldova?
Your answer should be compact. -29.99. In the year 2006, what is the difference between the % of value added in manufacturing of Estonia and % of value added in manufacturing of United States?
Provide a succinct answer. -1.36. In the year 2006, what is the difference between the % of value added in manufacturing of Moldova and % of value added in manufacturing of United States?
Offer a terse response. 28.63. In the year 2007, what is the difference between the % of value added in manufacturing of Costa Rica and % of value added in manufacturing of Estonia?
Give a very brief answer. 28.49. In the year 2007, what is the difference between the % of value added in manufacturing of Costa Rica and % of value added in manufacturing of Moldova?
Offer a very short reply. 1.74. In the year 2007, what is the difference between the % of value added in manufacturing of Costa Rica and % of value added in manufacturing of United States?
Your answer should be compact. 27.33. In the year 2007, what is the difference between the % of value added in manufacturing of Estonia and % of value added in manufacturing of Moldova?
Keep it short and to the point. -26.75. In the year 2007, what is the difference between the % of value added in manufacturing of Estonia and % of value added in manufacturing of United States?
Offer a very short reply. -1.16. In the year 2007, what is the difference between the % of value added in manufacturing in Moldova and % of value added in manufacturing in United States?
Keep it short and to the point. 25.59. In the year 2008, what is the difference between the % of value added in manufacturing in Costa Rica and % of value added in manufacturing in Estonia?
Offer a very short reply. 28.06. In the year 2008, what is the difference between the % of value added in manufacturing of Costa Rica and % of value added in manufacturing of Moldova?
Your answer should be very brief. 1.77. In the year 2008, what is the difference between the % of value added in manufacturing in Costa Rica and % of value added in manufacturing in United States?
Ensure brevity in your answer.  27.18. In the year 2008, what is the difference between the % of value added in manufacturing of Estonia and % of value added in manufacturing of Moldova?
Make the answer very short. -26.29. In the year 2008, what is the difference between the % of value added in manufacturing in Estonia and % of value added in manufacturing in United States?
Ensure brevity in your answer.  -0.89. In the year 2008, what is the difference between the % of value added in manufacturing of Moldova and % of value added in manufacturing of United States?
Keep it short and to the point. 25.4. What is the ratio of the % of value added in manufacturing of Costa Rica in 2001 to that in 2002?
Provide a short and direct response. 1.07. What is the ratio of the % of value added in manufacturing in Estonia in 2001 to that in 2002?
Give a very brief answer. 1.11. What is the ratio of the % of value added in manufacturing of Moldova in 2001 to that in 2002?
Provide a short and direct response. 1.1. What is the ratio of the % of value added in manufacturing in United States in 2001 to that in 2002?
Make the answer very short. 1.03. What is the ratio of the % of value added in manufacturing in Costa Rica in 2001 to that in 2003?
Give a very brief answer. 1.03. What is the ratio of the % of value added in manufacturing in Estonia in 2001 to that in 2003?
Give a very brief answer. 1.13. What is the ratio of the % of value added in manufacturing of Moldova in 2001 to that in 2003?
Provide a short and direct response. 1.13. What is the ratio of the % of value added in manufacturing of Costa Rica in 2001 to that in 2004?
Provide a succinct answer. 1.04. What is the ratio of the % of value added in manufacturing in Estonia in 2001 to that in 2004?
Offer a terse response. 1.28. What is the ratio of the % of value added in manufacturing in Moldova in 2001 to that in 2004?
Ensure brevity in your answer.  1.23. What is the ratio of the % of value added in manufacturing of United States in 2001 to that in 2004?
Offer a terse response. 1.02. What is the ratio of the % of value added in manufacturing in Costa Rica in 2001 to that in 2005?
Your answer should be compact. 1.05. What is the ratio of the % of value added in manufacturing in Estonia in 2001 to that in 2005?
Offer a terse response. 1.28. What is the ratio of the % of value added in manufacturing of Moldova in 2001 to that in 2005?
Provide a succinct answer. 1.3. What is the ratio of the % of value added in manufacturing in United States in 2001 to that in 2005?
Provide a short and direct response. 1.02. What is the ratio of the % of value added in manufacturing of Costa Rica in 2001 to that in 2006?
Ensure brevity in your answer.  1.11. What is the ratio of the % of value added in manufacturing in Estonia in 2001 to that in 2006?
Your answer should be compact. 1.32. What is the ratio of the % of value added in manufacturing of Moldova in 2001 to that in 2006?
Offer a terse response. 1.53. What is the ratio of the % of value added in manufacturing of United States in 2001 to that in 2006?
Ensure brevity in your answer.  1.08. What is the ratio of the % of value added in manufacturing in Costa Rica in 2001 to that in 2007?
Your answer should be compact. 1.11. What is the ratio of the % of value added in manufacturing of Estonia in 2001 to that in 2007?
Give a very brief answer. 1.31. What is the ratio of the % of value added in manufacturing of Moldova in 2001 to that in 2007?
Your answer should be compact. 1.65. What is the ratio of the % of value added in manufacturing of United States in 2001 to that in 2007?
Ensure brevity in your answer.  1.09. What is the ratio of the % of value added in manufacturing in Costa Rica in 2001 to that in 2008?
Make the answer very short. 1.09. What is the ratio of the % of value added in manufacturing of Estonia in 2001 to that in 2008?
Offer a terse response. 1.17. What is the ratio of the % of value added in manufacturing in Moldova in 2001 to that in 2008?
Make the answer very short. 1.61. What is the ratio of the % of value added in manufacturing in Costa Rica in 2002 to that in 2003?
Offer a terse response. 0.96. What is the ratio of the % of value added in manufacturing in Estonia in 2002 to that in 2003?
Offer a terse response. 1.02. What is the ratio of the % of value added in manufacturing of Moldova in 2002 to that in 2003?
Ensure brevity in your answer.  1.03. What is the ratio of the % of value added in manufacturing of United States in 2002 to that in 2003?
Your answer should be compact. 0.97. What is the ratio of the % of value added in manufacturing in Costa Rica in 2002 to that in 2004?
Offer a very short reply. 0.97. What is the ratio of the % of value added in manufacturing in Estonia in 2002 to that in 2004?
Make the answer very short. 1.15. What is the ratio of the % of value added in manufacturing in Moldova in 2002 to that in 2004?
Provide a short and direct response. 1.12. What is the ratio of the % of value added in manufacturing of United States in 2002 to that in 2004?
Your response must be concise. 0.99. What is the ratio of the % of value added in manufacturing in Costa Rica in 2002 to that in 2005?
Offer a terse response. 0.98. What is the ratio of the % of value added in manufacturing in Estonia in 2002 to that in 2005?
Your answer should be very brief. 1.15. What is the ratio of the % of value added in manufacturing of Moldova in 2002 to that in 2005?
Offer a terse response. 1.18. What is the ratio of the % of value added in manufacturing of United States in 2002 to that in 2005?
Make the answer very short. 0.99. What is the ratio of the % of value added in manufacturing in Costa Rica in 2002 to that in 2006?
Provide a short and direct response. 1.03. What is the ratio of the % of value added in manufacturing of Estonia in 2002 to that in 2006?
Your answer should be compact. 1.19. What is the ratio of the % of value added in manufacturing of Moldova in 2002 to that in 2006?
Make the answer very short. 1.39. What is the ratio of the % of value added in manufacturing in United States in 2002 to that in 2006?
Your response must be concise. 1.05. What is the ratio of the % of value added in manufacturing in Costa Rica in 2002 to that in 2007?
Give a very brief answer. 1.04. What is the ratio of the % of value added in manufacturing in Estonia in 2002 to that in 2007?
Ensure brevity in your answer.  1.18. What is the ratio of the % of value added in manufacturing of Moldova in 2002 to that in 2007?
Ensure brevity in your answer.  1.51. What is the ratio of the % of value added in manufacturing of United States in 2002 to that in 2007?
Ensure brevity in your answer.  1.06. What is the ratio of the % of value added in manufacturing in Costa Rica in 2002 to that in 2008?
Provide a succinct answer. 1.01. What is the ratio of the % of value added in manufacturing of Estonia in 2002 to that in 2008?
Provide a succinct answer. 1.05. What is the ratio of the % of value added in manufacturing in Moldova in 2002 to that in 2008?
Keep it short and to the point. 1.47. What is the ratio of the % of value added in manufacturing of United States in 2002 to that in 2008?
Offer a terse response. 0.97. What is the ratio of the % of value added in manufacturing of Costa Rica in 2003 to that in 2004?
Your answer should be compact. 1.01. What is the ratio of the % of value added in manufacturing of Estonia in 2003 to that in 2004?
Offer a terse response. 1.13. What is the ratio of the % of value added in manufacturing in Moldova in 2003 to that in 2004?
Ensure brevity in your answer.  1.08. What is the ratio of the % of value added in manufacturing of United States in 2003 to that in 2004?
Your answer should be very brief. 1.02. What is the ratio of the % of value added in manufacturing in Costa Rica in 2003 to that in 2005?
Make the answer very short. 1.02. What is the ratio of the % of value added in manufacturing of Estonia in 2003 to that in 2005?
Your answer should be compact. 1.13. What is the ratio of the % of value added in manufacturing in Moldova in 2003 to that in 2005?
Your answer should be compact. 1.15. What is the ratio of the % of value added in manufacturing of United States in 2003 to that in 2005?
Your response must be concise. 1.03. What is the ratio of the % of value added in manufacturing of Costa Rica in 2003 to that in 2006?
Offer a very short reply. 1.08. What is the ratio of the % of value added in manufacturing of Estonia in 2003 to that in 2006?
Give a very brief answer. 1.16. What is the ratio of the % of value added in manufacturing in Moldova in 2003 to that in 2006?
Keep it short and to the point. 1.35. What is the ratio of the % of value added in manufacturing in United States in 2003 to that in 2006?
Your answer should be compact. 1.08. What is the ratio of the % of value added in manufacturing of Costa Rica in 2003 to that in 2007?
Ensure brevity in your answer.  1.09. What is the ratio of the % of value added in manufacturing of Estonia in 2003 to that in 2007?
Ensure brevity in your answer.  1.16. What is the ratio of the % of value added in manufacturing in Moldova in 2003 to that in 2007?
Give a very brief answer. 1.46. What is the ratio of the % of value added in manufacturing of United States in 2003 to that in 2007?
Give a very brief answer. 1.1. What is the ratio of the % of value added in manufacturing of Costa Rica in 2003 to that in 2008?
Provide a short and direct response. 1.06. What is the ratio of the % of value added in manufacturing in Estonia in 2003 to that in 2008?
Your answer should be compact. 1.03. What is the ratio of the % of value added in manufacturing in Moldova in 2003 to that in 2008?
Provide a succinct answer. 1.42. What is the ratio of the % of value added in manufacturing in Costa Rica in 2004 to that in 2005?
Your answer should be very brief. 1.01. What is the ratio of the % of value added in manufacturing of Moldova in 2004 to that in 2005?
Provide a short and direct response. 1.06. What is the ratio of the % of value added in manufacturing in United States in 2004 to that in 2005?
Your answer should be compact. 1. What is the ratio of the % of value added in manufacturing in Costa Rica in 2004 to that in 2006?
Your answer should be very brief. 1.07. What is the ratio of the % of value added in manufacturing of Estonia in 2004 to that in 2006?
Your answer should be compact. 1.03. What is the ratio of the % of value added in manufacturing of Moldova in 2004 to that in 2006?
Make the answer very short. 1.25. What is the ratio of the % of value added in manufacturing of United States in 2004 to that in 2006?
Your answer should be compact. 1.06. What is the ratio of the % of value added in manufacturing of Costa Rica in 2004 to that in 2007?
Keep it short and to the point. 1.07. What is the ratio of the % of value added in manufacturing of Estonia in 2004 to that in 2007?
Give a very brief answer. 1.03. What is the ratio of the % of value added in manufacturing of Moldova in 2004 to that in 2007?
Make the answer very short. 1.35. What is the ratio of the % of value added in manufacturing in United States in 2004 to that in 2007?
Provide a short and direct response. 1.07. What is the ratio of the % of value added in manufacturing in Costa Rica in 2004 to that in 2008?
Keep it short and to the point. 1.05. What is the ratio of the % of value added in manufacturing of Estonia in 2004 to that in 2008?
Make the answer very short. 0.91. What is the ratio of the % of value added in manufacturing in Moldova in 2004 to that in 2008?
Your answer should be compact. 1.31. What is the ratio of the % of value added in manufacturing of United States in 2004 to that in 2008?
Your response must be concise. 0.98. What is the ratio of the % of value added in manufacturing of Costa Rica in 2005 to that in 2006?
Provide a short and direct response. 1.05. What is the ratio of the % of value added in manufacturing of Moldova in 2005 to that in 2006?
Keep it short and to the point. 1.18. What is the ratio of the % of value added in manufacturing of United States in 2005 to that in 2006?
Ensure brevity in your answer.  1.06. What is the ratio of the % of value added in manufacturing in Costa Rica in 2005 to that in 2007?
Ensure brevity in your answer.  1.06. What is the ratio of the % of value added in manufacturing in Estonia in 2005 to that in 2007?
Your answer should be very brief. 1.03. What is the ratio of the % of value added in manufacturing in Moldova in 2005 to that in 2007?
Make the answer very short. 1.27. What is the ratio of the % of value added in manufacturing in United States in 2005 to that in 2007?
Offer a very short reply. 1.07. What is the ratio of the % of value added in manufacturing of Costa Rica in 2005 to that in 2008?
Offer a terse response. 1.03. What is the ratio of the % of value added in manufacturing of Estonia in 2005 to that in 2008?
Give a very brief answer. 0.91. What is the ratio of the % of value added in manufacturing in Moldova in 2005 to that in 2008?
Provide a short and direct response. 1.24. What is the ratio of the % of value added in manufacturing of United States in 2005 to that in 2008?
Ensure brevity in your answer.  0.98. What is the ratio of the % of value added in manufacturing in Moldova in 2006 to that in 2007?
Provide a succinct answer. 1.08. What is the ratio of the % of value added in manufacturing of United States in 2006 to that in 2007?
Your response must be concise. 1.01. What is the ratio of the % of value added in manufacturing in Costa Rica in 2006 to that in 2008?
Offer a terse response. 0.98. What is the ratio of the % of value added in manufacturing of Estonia in 2006 to that in 2008?
Offer a terse response. 0.89. What is the ratio of the % of value added in manufacturing of Moldova in 2006 to that in 2008?
Make the answer very short. 1.05. What is the ratio of the % of value added in manufacturing of United States in 2006 to that in 2008?
Provide a succinct answer. 0.92. What is the ratio of the % of value added in manufacturing of Costa Rica in 2007 to that in 2008?
Offer a terse response. 0.97. What is the ratio of the % of value added in manufacturing of Estonia in 2007 to that in 2008?
Offer a very short reply. 0.89. What is the ratio of the % of value added in manufacturing of Moldova in 2007 to that in 2008?
Give a very brief answer. 0.97. What is the ratio of the % of value added in manufacturing in United States in 2007 to that in 2008?
Your answer should be compact. 0.91. What is the difference between the highest and the second highest % of value added in manufacturing in Costa Rica?
Make the answer very short. 1.16. What is the difference between the highest and the second highest % of value added in manufacturing of Estonia?
Provide a short and direct response. 1.63. What is the difference between the highest and the second highest % of value added in manufacturing in Moldova?
Offer a very short reply. 5.67. What is the difference between the highest and the second highest % of value added in manufacturing in United States?
Your answer should be compact. 0.03. What is the difference between the highest and the lowest % of value added in manufacturing in Costa Rica?
Provide a short and direct response. 4.69. What is the difference between the highest and the lowest % of value added in manufacturing of Estonia?
Give a very brief answer. 3.92. What is the difference between the highest and the lowest % of value added in manufacturing of Moldova?
Offer a very short reply. 25.48. What is the difference between the highest and the lowest % of value added in manufacturing of United States?
Offer a very short reply. 1.29. 